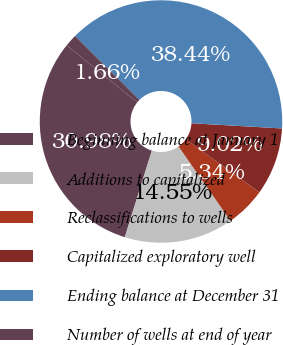<chart> <loc_0><loc_0><loc_500><loc_500><pie_chart><fcel>Beginning balance at January 1<fcel>Additions to capitalized<fcel>Reclassifications to wells<fcel>Capitalized exploratory well<fcel>Ending balance at December 31<fcel>Number of wells at end of year<nl><fcel>30.98%<fcel>14.55%<fcel>5.34%<fcel>9.02%<fcel>38.44%<fcel>1.66%<nl></chart> 